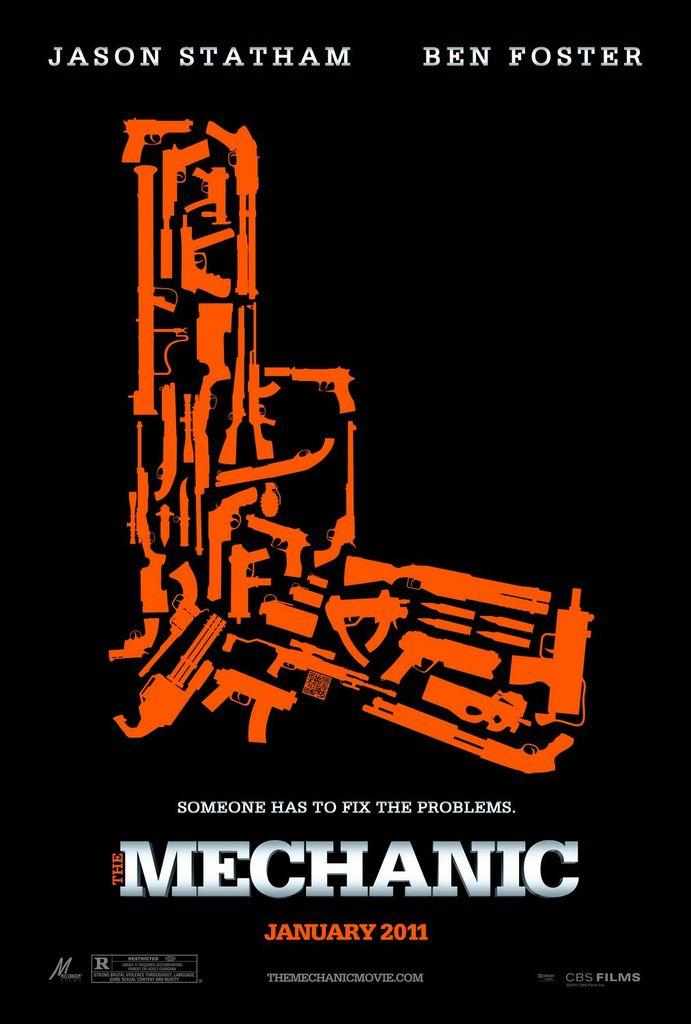<image>
Relay a brief, clear account of the picture shown. A movie poster about The Mechanic with an abstract orange gun photo in the center and the names Jason Statham and Ben Foster above 